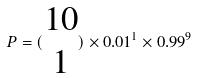Convert formula to latex. <formula><loc_0><loc_0><loc_500><loc_500>P = ( \begin{matrix} 1 0 \\ 1 \end{matrix} ) \times 0 . 0 1 ^ { 1 } \times 0 . 9 9 ^ { 9 }</formula> 